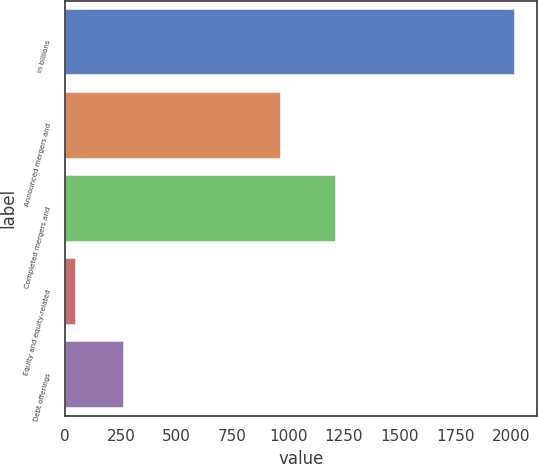<chart> <loc_0><loc_0><loc_500><loc_500><bar_chart><fcel>in billions<fcel>Announced mergers and<fcel>Completed mergers and<fcel>Equity and equity-related<fcel>Debt offerings<nl><fcel>2016<fcel>969<fcel>1215<fcel>49<fcel>266<nl></chart> 